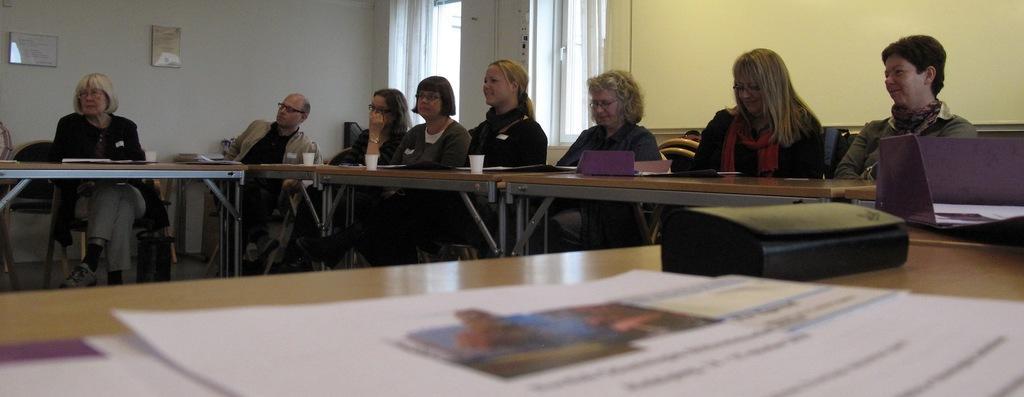Can you describe this image briefly? In the picture there are many people present, they are sitting on the chairs with the table in front of them, on the table there are glasses, there are papers, there is a laptop, there is a wall, on the wall there are windows present, there are frames present on the wall. 